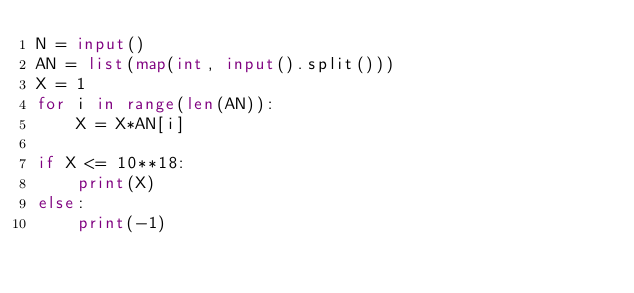Convert code to text. <code><loc_0><loc_0><loc_500><loc_500><_Python_>N = input()
AN = list(map(int, input().split()))
X = 1
for i in range(len(AN)):
    X = X*AN[i]

if X <= 10**18:
    print(X)
else:
    print(-1)</code> 